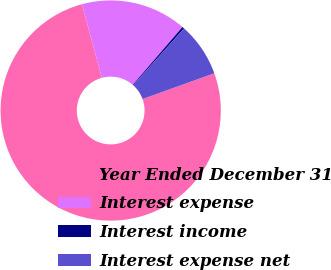Convert chart. <chart><loc_0><loc_0><loc_500><loc_500><pie_chart><fcel>Year Ended December 31<fcel>Interest expense<fcel>Interest income<fcel>Interest expense net<nl><fcel>76.29%<fcel>15.5%<fcel>0.3%<fcel>7.9%<nl></chart> 